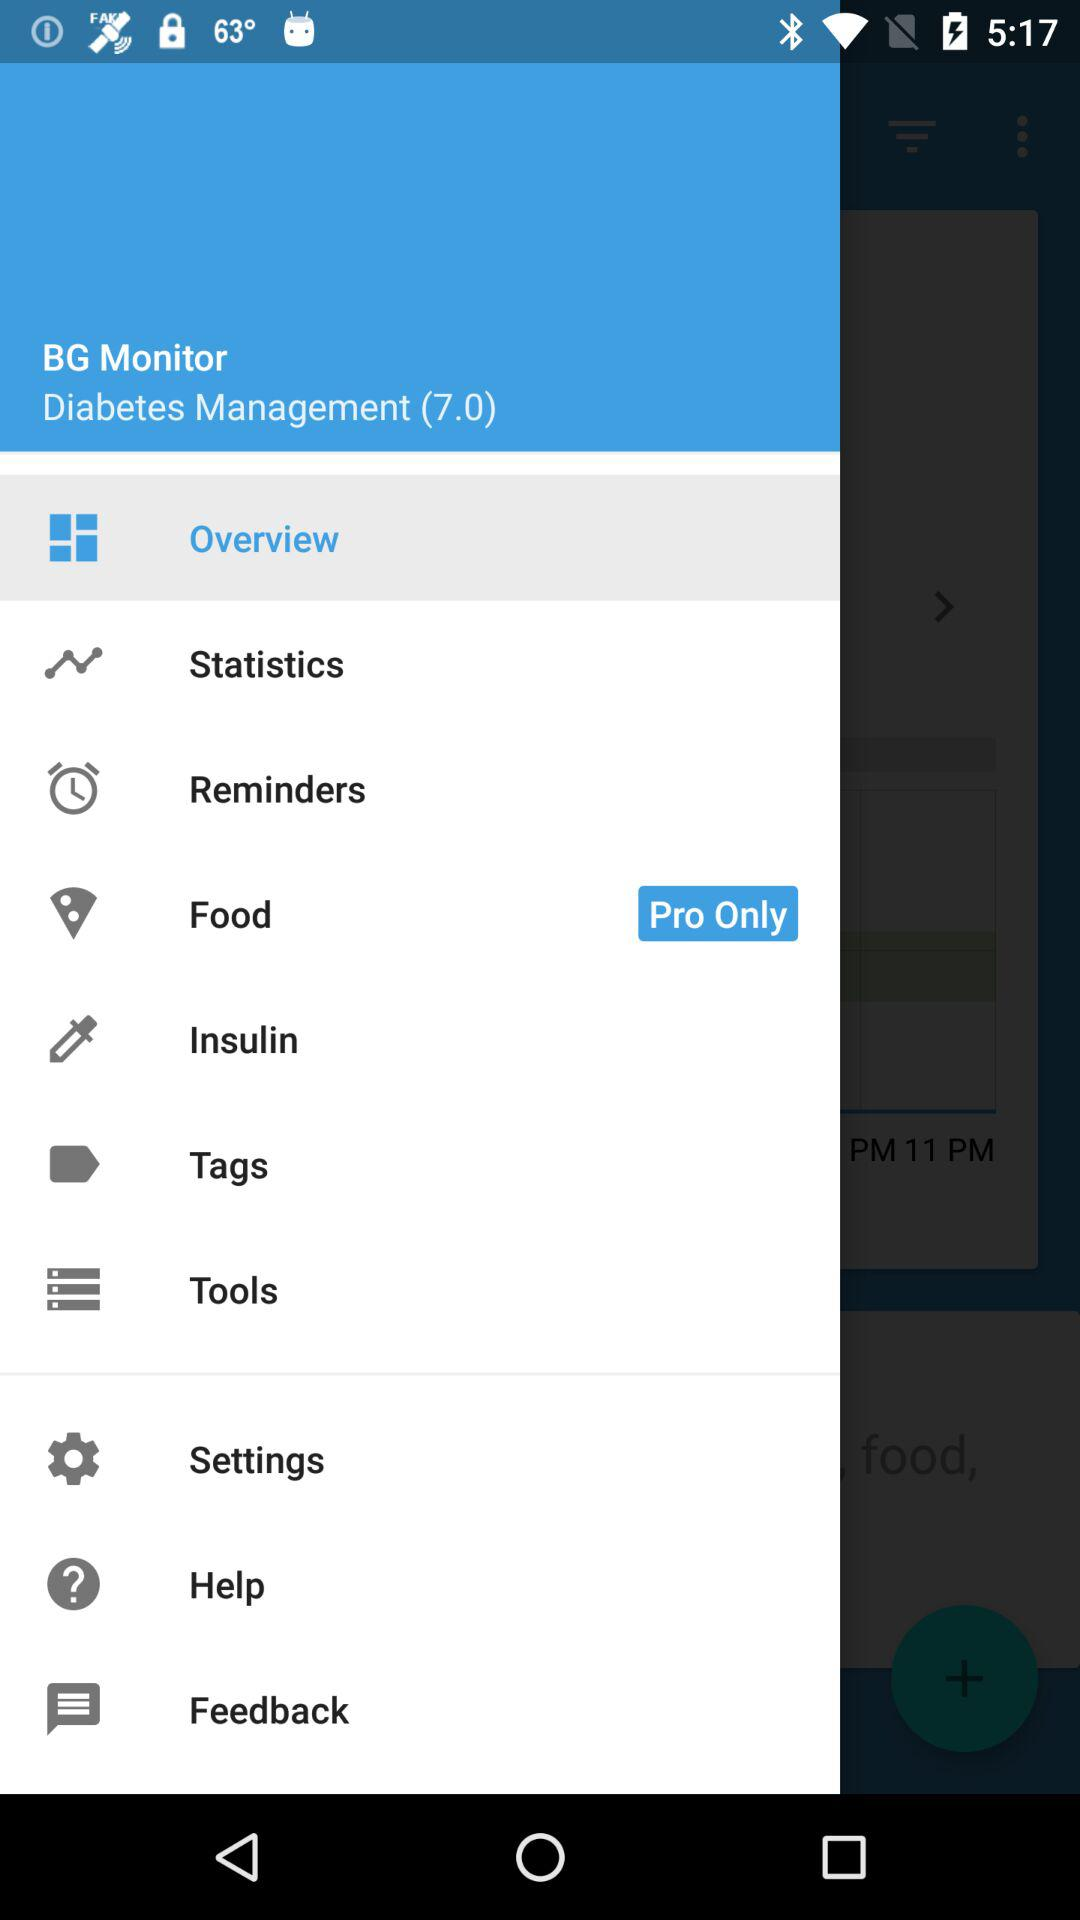How many notifications are there in "Settings"?
When the provided information is insufficient, respond with <no answer>. <no answer> 